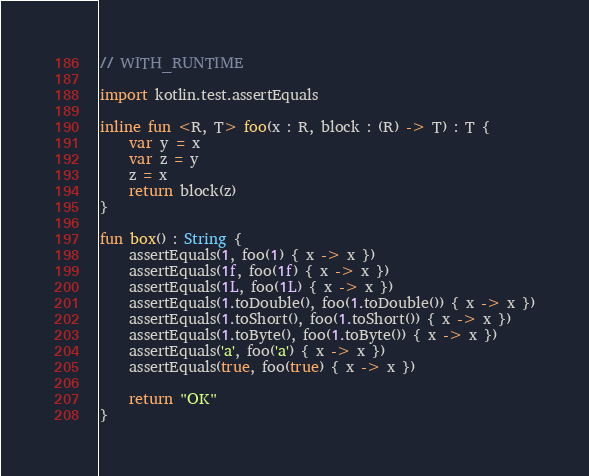Convert code to text. <code><loc_0><loc_0><loc_500><loc_500><_Kotlin_>// WITH_RUNTIME

import kotlin.test.assertEquals

inline fun <R, T> foo(x : R, block : (R) -> T) : T {
    var y = x
    var z = y
    z = x
    return block(z)
}

fun box() : String {
    assertEquals(1, foo(1) { x -> x })
    assertEquals(1f, foo(1f) { x -> x })
    assertEquals(1L, foo(1L) { x -> x })
    assertEquals(1.toDouble(), foo(1.toDouble()) { x -> x })
    assertEquals(1.toShort(), foo(1.toShort()) { x -> x })
    assertEquals(1.toByte(), foo(1.toByte()) { x -> x })
    assertEquals('a', foo('a') { x -> x })
    assertEquals(true, foo(true) { x -> x })

    return "OK"
}
</code> 